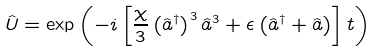Convert formula to latex. <formula><loc_0><loc_0><loc_500><loc_500>\hat { U } = \exp \left ( - i \left [ \frac { \chi } { 3 } \left ( \hat { a } ^ { \dagger } \right ) ^ { 3 } \hat { a } ^ { 3 } + \epsilon \left ( \hat { a } ^ { \dagger } + \hat { a } \right ) \right ] t \right )</formula> 